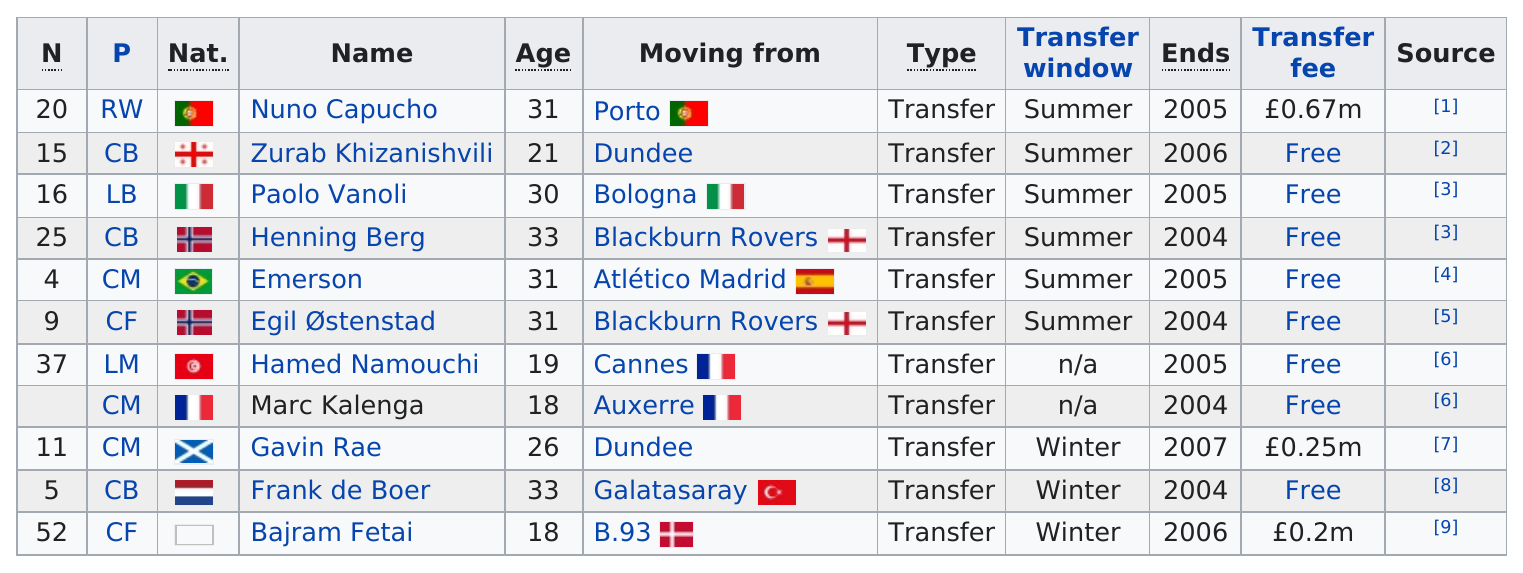Outline some significant characteristics in this image. Henning Berg, the former Blackburn Rovers player, moved from where he was previously based. Marc Kalenga and Gavin Rae played the position of Central Midfielder (CM). As informações recentes revelam, o jogador Nuno Capucho é o que teve o transfer fee mais alto. The number of players who are either 21 years old or 33 years old is [number]. According to the information provided, the difference in age between Palo Vanoli and Marc Kalenga is 12 years. 